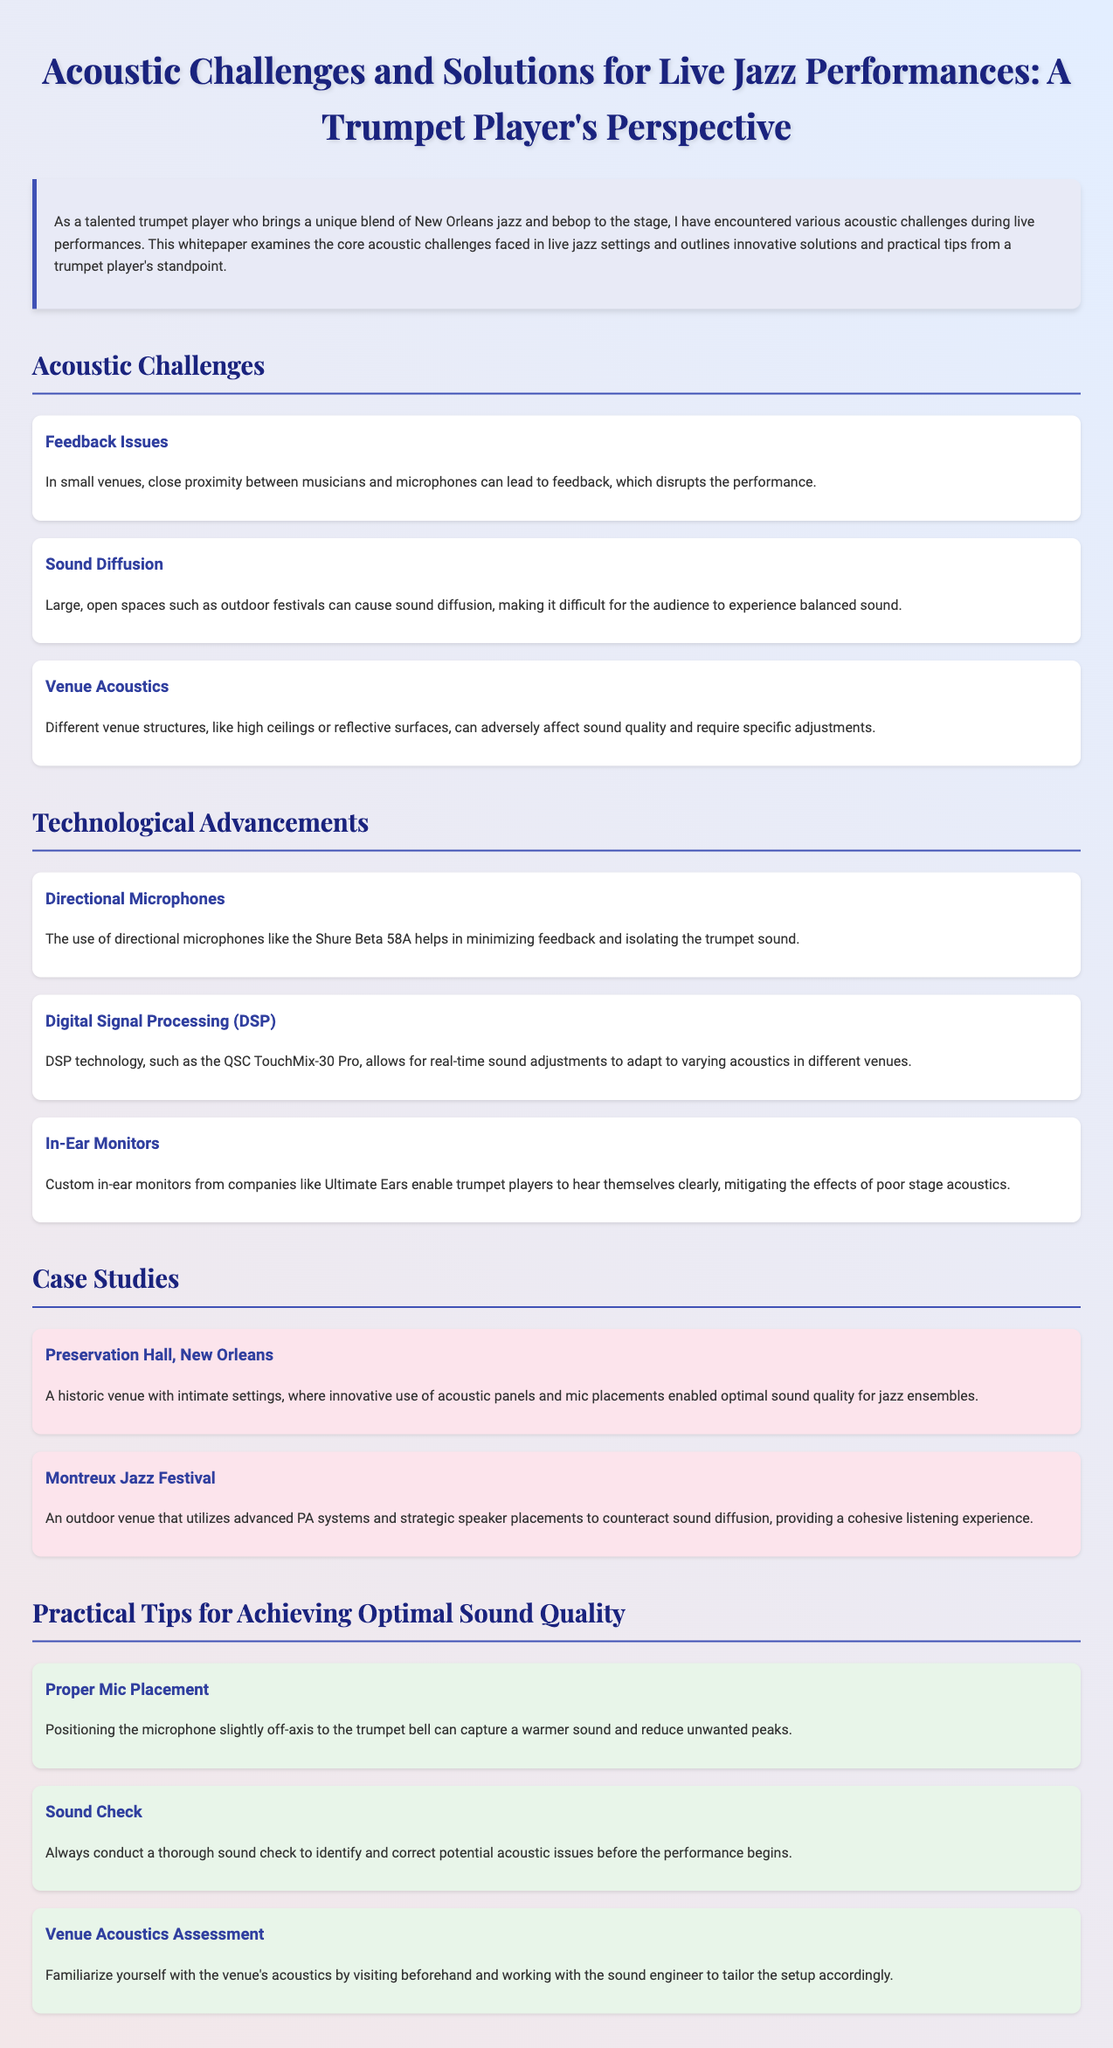What are the two main genres combined by the trumpet player? The trumpet player's unique blend includes New Orleans jazz and bebop.
Answer: New Orleans jazz and bebop What is a common feedback issue faced in small venues? Close proximity between musicians and microphones can lead to feedback.
Answer: Feedback Which directional microphone is mentioned in the document? The Shure Beta 58A is noted for its effectiveness in minimizing feedback.
Answer: Shure Beta 58A What type of technology allows for real-time sound adjustments? Digital Signal Processing (DSP) is highlighted for adapting to varying acoustics.
Answer: Digital Signal Processing (DSP) What venue is cited as a case study for its acoustic panels? Preservation Hall, New Orleans, is known for its innovative use of acoustic panels.
Answer: Preservation Hall, New Orleans How should a microphone be positioned for optimal sound capture? Positioning the microphone slightly off-axis to the trumpet bell is recommended.
Answer: Off-axis What is a crucial step before a performance according to practical tips? Conducting a thorough sound check is essential to identify acoustic issues.
Answer: Sound check What outdoor venue uses advanced PA systems? Montreux Jazz Festival utilizes advanced PA systems for sound clarity.
Answer: Montreux Jazz Festival 